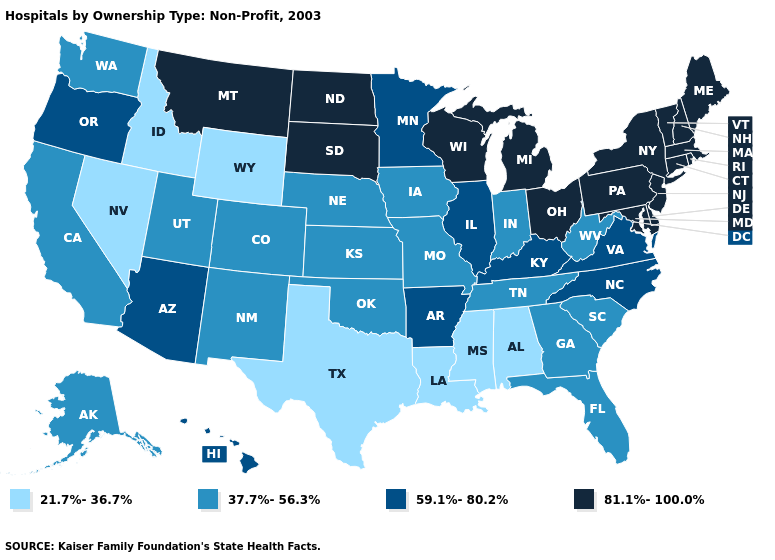What is the value of Kentucky?
Be succinct. 59.1%-80.2%. Name the states that have a value in the range 21.7%-36.7%?
Answer briefly. Alabama, Idaho, Louisiana, Mississippi, Nevada, Texas, Wyoming. What is the value of Minnesota?
Quick response, please. 59.1%-80.2%. Name the states that have a value in the range 59.1%-80.2%?
Be succinct. Arizona, Arkansas, Hawaii, Illinois, Kentucky, Minnesota, North Carolina, Oregon, Virginia. What is the value of North Dakota?
Concise answer only. 81.1%-100.0%. What is the value of Minnesota?
Quick response, please. 59.1%-80.2%. What is the value of Montana?
Short answer required. 81.1%-100.0%. What is the value of Massachusetts?
Give a very brief answer. 81.1%-100.0%. Name the states that have a value in the range 37.7%-56.3%?
Quick response, please. Alaska, California, Colorado, Florida, Georgia, Indiana, Iowa, Kansas, Missouri, Nebraska, New Mexico, Oklahoma, South Carolina, Tennessee, Utah, Washington, West Virginia. What is the lowest value in states that border Texas?
Short answer required. 21.7%-36.7%. Does the map have missing data?
Give a very brief answer. No. Which states have the highest value in the USA?
Write a very short answer. Connecticut, Delaware, Maine, Maryland, Massachusetts, Michigan, Montana, New Hampshire, New Jersey, New York, North Dakota, Ohio, Pennsylvania, Rhode Island, South Dakota, Vermont, Wisconsin. Name the states that have a value in the range 37.7%-56.3%?
Quick response, please. Alaska, California, Colorado, Florida, Georgia, Indiana, Iowa, Kansas, Missouri, Nebraska, New Mexico, Oklahoma, South Carolina, Tennessee, Utah, Washington, West Virginia. Does the first symbol in the legend represent the smallest category?
Answer briefly. Yes. Name the states that have a value in the range 59.1%-80.2%?
Give a very brief answer. Arizona, Arkansas, Hawaii, Illinois, Kentucky, Minnesota, North Carolina, Oregon, Virginia. 